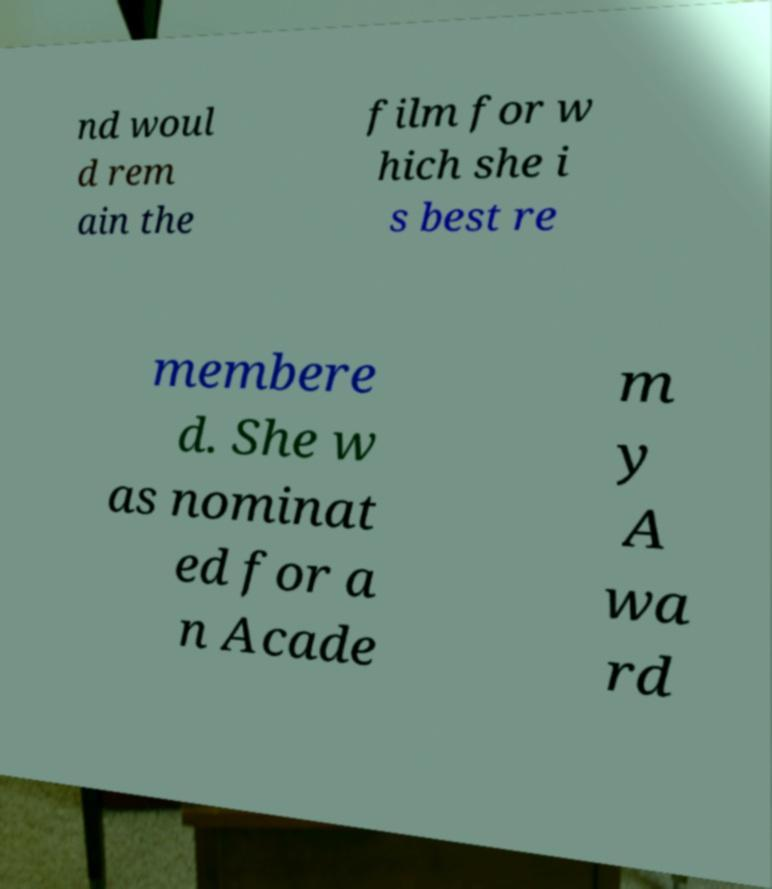Could you extract and type out the text from this image? nd woul d rem ain the film for w hich she i s best re membere d. She w as nominat ed for a n Acade m y A wa rd 